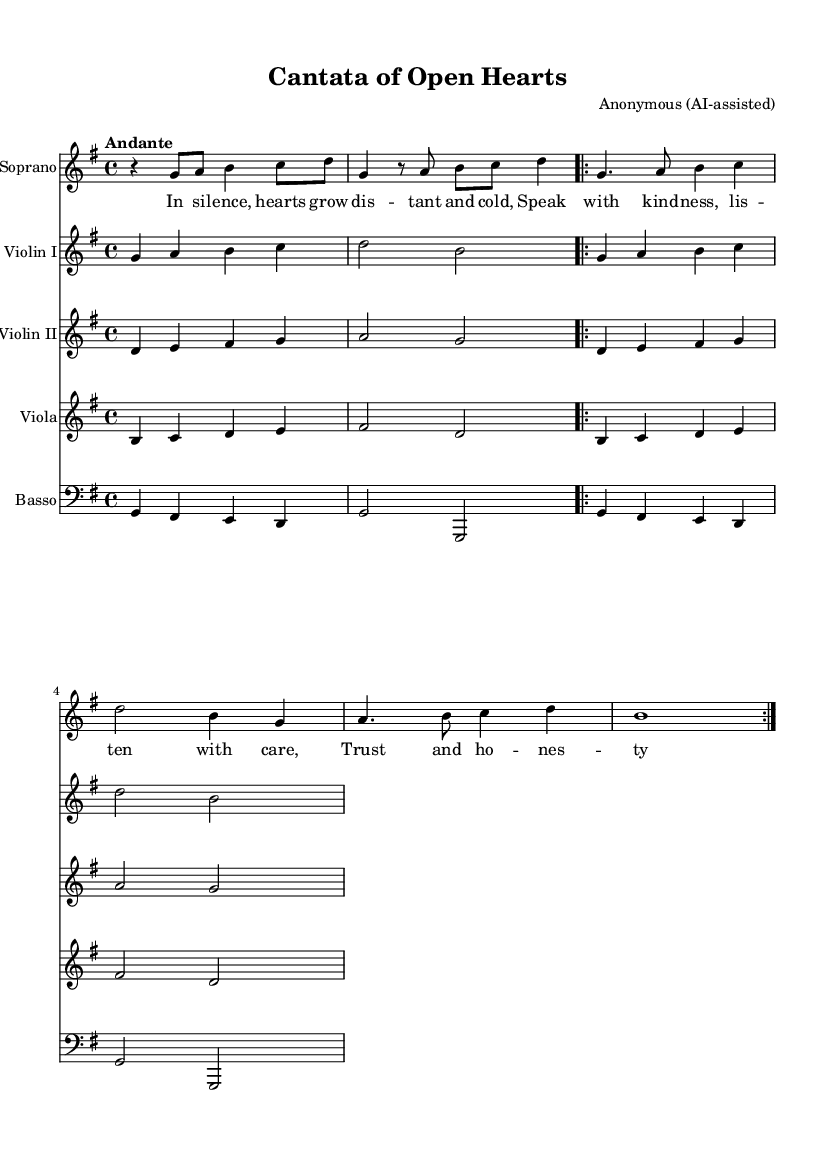What is the key signature of this music? The key signature shows one sharp (F#), indicating that it is set in G major.
Answer: G major What is the time signature of this music? The time signature is located at the beginning of the score and indicates that there are four beats per measure, which is represented as 4/4.
Answer: 4/4 What is the indicated tempo for this piece? The tempo marking "Andante" is located at the beginning of the score, indicating a moderate pace of walking speed, typically around 76-108 beats per minute.
Answer: Andante What vocal type is featured in this cantata? The clef and staff labeled "Soprano" specify the vocal part, which indicates that this piece is concentrated around a soprano voice.
Answer: Soprano How many measures are in the first recitative section? Counting the first segments, there are 5 measures before the transition to the aria section; hence the calculation includes each measure up to the end of that part.
Answer: 5 What is the theme of the lyrics in this cantata? The lyrics speak to the importance of open communication, kindness, and trust within relationships, emphasizing their role in forming strong connections.
Answer: Open communication 